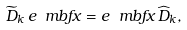<formula> <loc_0><loc_0><loc_500><loc_500>\widetilde { D } _ { k } \, e _ { \ } m b f { x } = e _ { \ } m b f { x } \, \widehat { D } _ { k } ,</formula> 